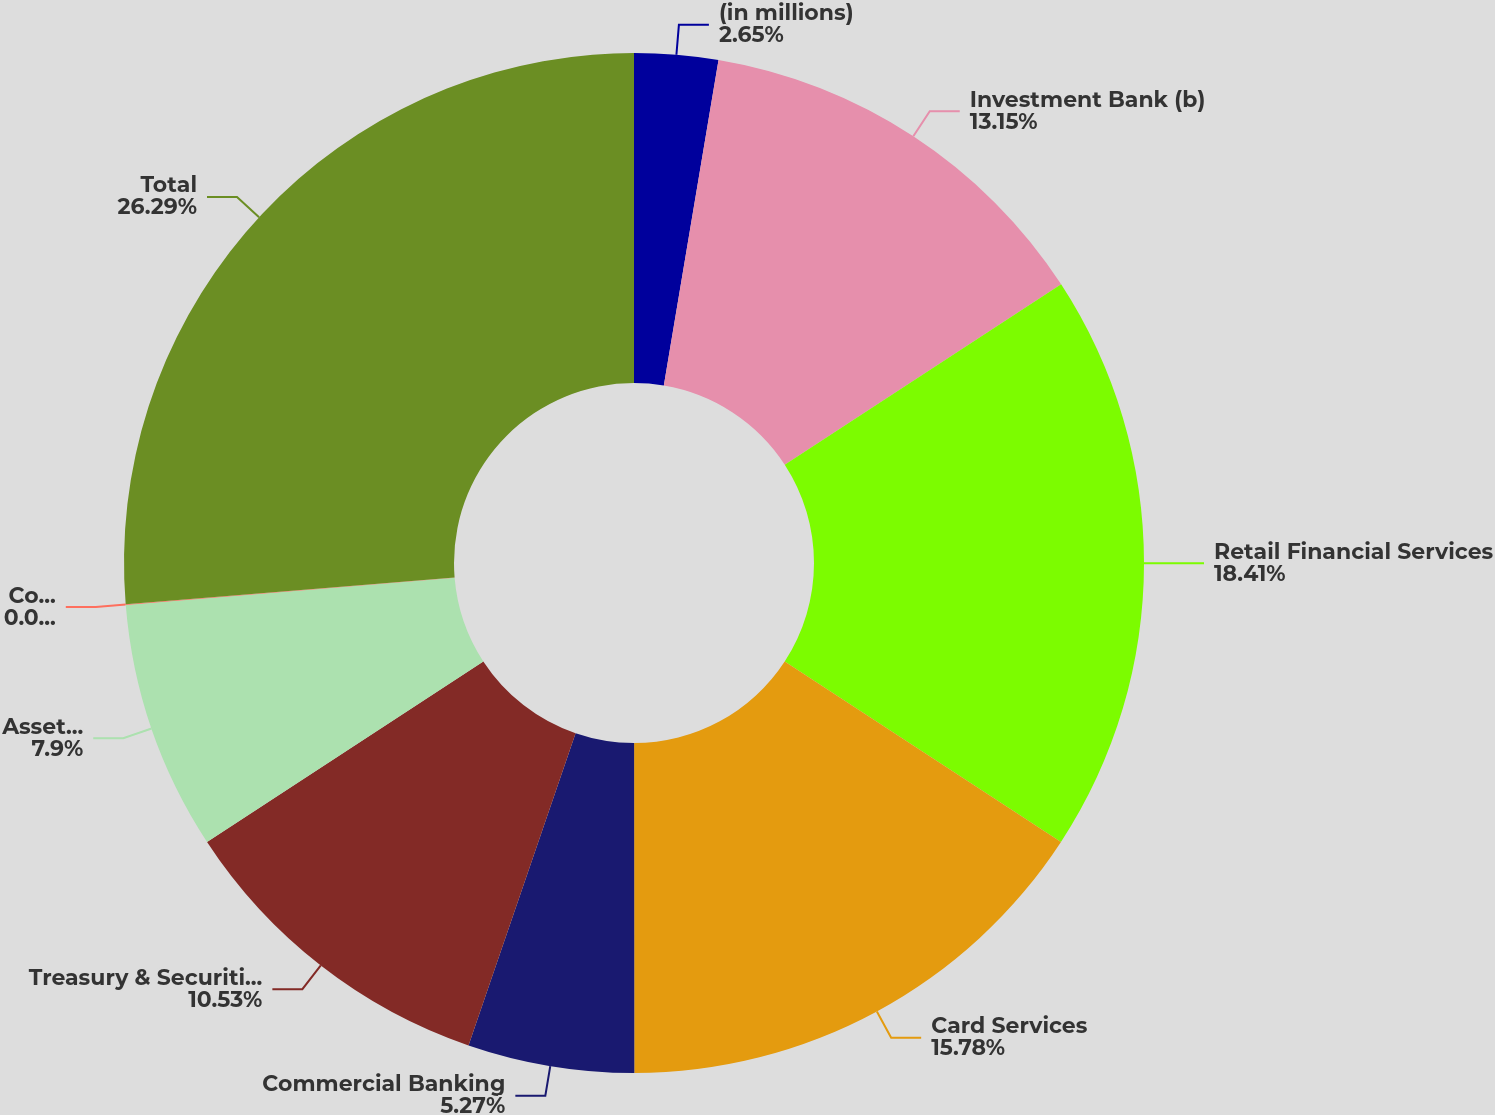Convert chart. <chart><loc_0><loc_0><loc_500><loc_500><pie_chart><fcel>(in millions)<fcel>Investment Bank (b)<fcel>Retail Financial Services<fcel>Card Services<fcel>Commercial Banking<fcel>Treasury & Securities Services<fcel>Asset Management<fcel>Corporate/Private Equity (b)<fcel>Total<nl><fcel>2.65%<fcel>13.15%<fcel>18.41%<fcel>15.78%<fcel>5.27%<fcel>10.53%<fcel>7.9%<fcel>0.02%<fcel>26.29%<nl></chart> 